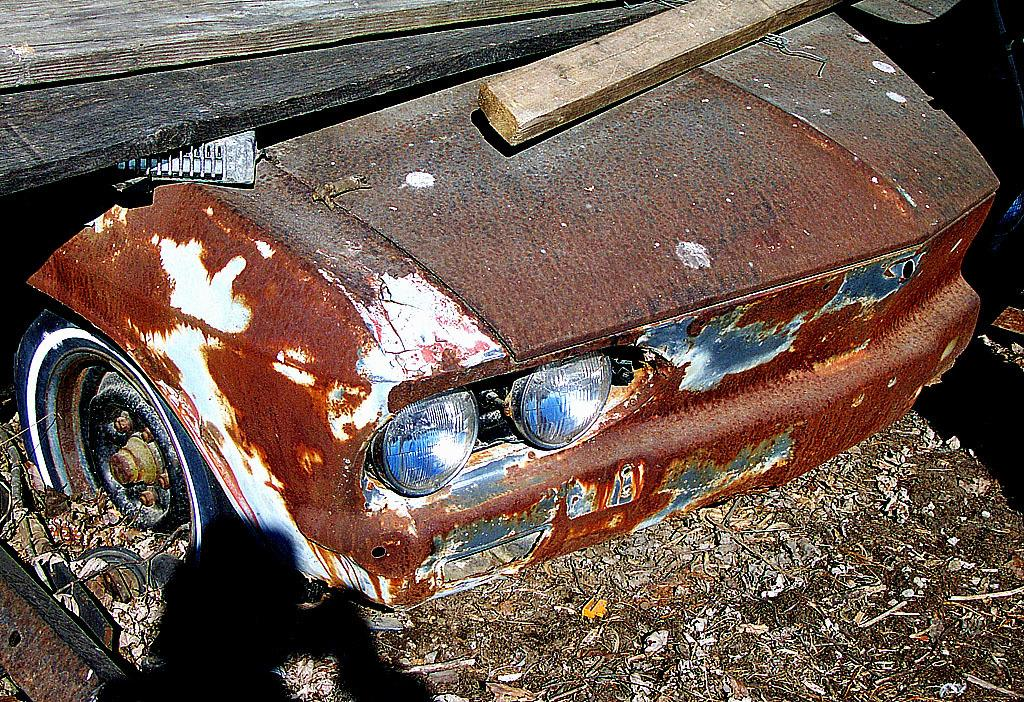What type of vehicle is in the image? There is an old rusted car in the image. Are there any objects on the car? Yes, there are wooden sticks on the car. What can be seen at the bottom of the image? There is garbage visible at the bottom of the image. What type of wave can be seen in the image? There is no wave present in the image; it features an old rusted car with wooden sticks and garbage. 